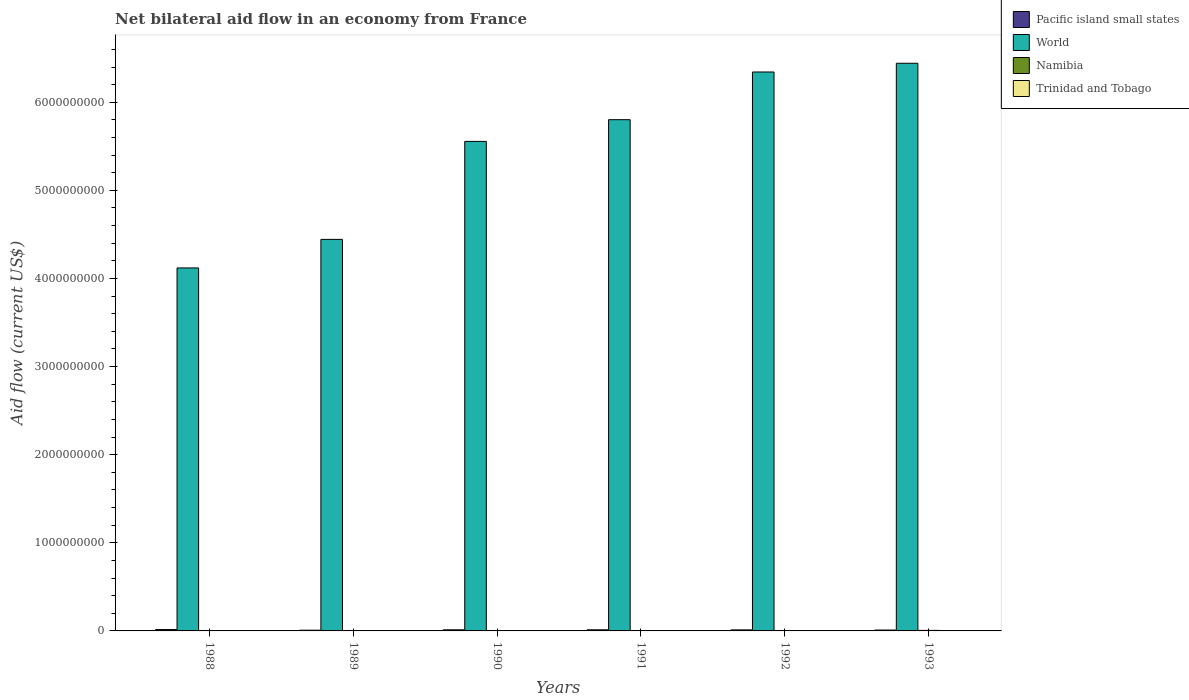How many different coloured bars are there?
Make the answer very short. 4. How many bars are there on the 1st tick from the left?
Your answer should be very brief. 4. What is the label of the 4th group of bars from the left?
Your response must be concise. 1991. What is the net bilateral aid flow in Namibia in 1989?
Your answer should be compact. 5.90e+05. Across all years, what is the maximum net bilateral aid flow in Pacific island small states?
Provide a short and direct response. 1.54e+07. Across all years, what is the minimum net bilateral aid flow in Pacific island small states?
Give a very brief answer. 8.03e+06. In which year was the net bilateral aid flow in Trinidad and Tobago minimum?
Your answer should be very brief. 1991. What is the total net bilateral aid flow in Pacific island small states in the graph?
Your answer should be compact. 7.01e+07. What is the difference between the net bilateral aid flow in Trinidad and Tobago in 1988 and that in 1992?
Ensure brevity in your answer.  -1.00e+05. What is the difference between the net bilateral aid flow in Trinidad and Tobago in 1988 and the net bilateral aid flow in Pacific island small states in 1989?
Provide a short and direct response. -7.72e+06. In the year 1992, what is the difference between the net bilateral aid flow in Namibia and net bilateral aid flow in Trinidad and Tobago?
Offer a terse response. 3.32e+06. What is the ratio of the net bilateral aid flow in Trinidad and Tobago in 1988 to that in 1989?
Provide a succinct answer. 1.03. What is the difference between the highest and the second highest net bilateral aid flow in Namibia?
Ensure brevity in your answer.  2.13e+06. What is the difference between the highest and the lowest net bilateral aid flow in Trinidad and Tobago?
Your response must be concise. 1.60e+05. Is it the case that in every year, the sum of the net bilateral aid flow in Pacific island small states and net bilateral aid flow in Namibia is greater than the sum of net bilateral aid flow in Trinidad and Tobago and net bilateral aid flow in World?
Offer a very short reply. Yes. What does the 4th bar from the left in 1989 represents?
Offer a very short reply. Trinidad and Tobago. What does the 1st bar from the right in 1991 represents?
Offer a terse response. Trinidad and Tobago. Is it the case that in every year, the sum of the net bilateral aid flow in World and net bilateral aid flow in Trinidad and Tobago is greater than the net bilateral aid flow in Pacific island small states?
Offer a terse response. Yes. How many bars are there?
Offer a very short reply. 24. Are all the bars in the graph horizontal?
Make the answer very short. No. What is the difference between two consecutive major ticks on the Y-axis?
Offer a very short reply. 1.00e+09. Where does the legend appear in the graph?
Offer a terse response. Top right. How many legend labels are there?
Your response must be concise. 4. What is the title of the graph?
Your answer should be compact. Net bilateral aid flow in an economy from France. Does "Bolivia" appear as one of the legend labels in the graph?
Your answer should be very brief. No. What is the label or title of the Y-axis?
Your answer should be very brief. Aid flow (current US$). What is the Aid flow (current US$) of Pacific island small states in 1988?
Your answer should be compact. 1.54e+07. What is the Aid flow (current US$) in World in 1988?
Offer a very short reply. 4.12e+09. What is the Aid flow (current US$) of Pacific island small states in 1989?
Your response must be concise. 8.03e+06. What is the Aid flow (current US$) in World in 1989?
Offer a terse response. 4.44e+09. What is the Aid flow (current US$) in Namibia in 1989?
Give a very brief answer. 5.90e+05. What is the Aid flow (current US$) of Trinidad and Tobago in 1989?
Your answer should be compact. 3.00e+05. What is the Aid flow (current US$) in Pacific island small states in 1990?
Offer a very short reply. 1.25e+07. What is the Aid flow (current US$) of World in 1990?
Make the answer very short. 5.56e+09. What is the Aid flow (current US$) of Namibia in 1990?
Your answer should be very brief. 1.20e+06. What is the Aid flow (current US$) of Pacific island small states in 1991?
Make the answer very short. 1.26e+07. What is the Aid flow (current US$) in World in 1991?
Make the answer very short. 5.80e+09. What is the Aid flow (current US$) in Namibia in 1991?
Your answer should be very brief. 4.02e+06. What is the Aid flow (current US$) in Pacific island small states in 1992?
Offer a very short reply. 1.16e+07. What is the Aid flow (current US$) of World in 1992?
Provide a succinct answer. 6.34e+09. What is the Aid flow (current US$) of Namibia in 1992?
Your response must be concise. 3.73e+06. What is the Aid flow (current US$) of Trinidad and Tobago in 1992?
Give a very brief answer. 4.10e+05. What is the Aid flow (current US$) in Pacific island small states in 1993?
Your answer should be compact. 9.95e+06. What is the Aid flow (current US$) of World in 1993?
Offer a very short reply. 6.44e+09. What is the Aid flow (current US$) in Namibia in 1993?
Offer a very short reply. 6.15e+06. Across all years, what is the maximum Aid flow (current US$) in Pacific island small states?
Provide a short and direct response. 1.54e+07. Across all years, what is the maximum Aid flow (current US$) of World?
Your response must be concise. 6.44e+09. Across all years, what is the maximum Aid flow (current US$) in Namibia?
Offer a terse response. 6.15e+06. Across all years, what is the maximum Aid flow (current US$) in Trinidad and Tobago?
Keep it short and to the point. 4.40e+05. Across all years, what is the minimum Aid flow (current US$) of Pacific island small states?
Provide a succinct answer. 8.03e+06. Across all years, what is the minimum Aid flow (current US$) of World?
Your answer should be very brief. 4.12e+09. Across all years, what is the minimum Aid flow (current US$) in Namibia?
Offer a terse response. 10000. What is the total Aid flow (current US$) of Pacific island small states in the graph?
Your response must be concise. 7.01e+07. What is the total Aid flow (current US$) of World in the graph?
Your answer should be compact. 3.27e+1. What is the total Aid flow (current US$) in Namibia in the graph?
Provide a short and direct response. 1.57e+07. What is the total Aid flow (current US$) of Trinidad and Tobago in the graph?
Ensure brevity in your answer.  2.04e+06. What is the difference between the Aid flow (current US$) in Pacific island small states in 1988 and that in 1989?
Keep it short and to the point. 7.34e+06. What is the difference between the Aid flow (current US$) in World in 1988 and that in 1989?
Keep it short and to the point. -3.24e+08. What is the difference between the Aid flow (current US$) in Namibia in 1988 and that in 1989?
Offer a very short reply. -5.80e+05. What is the difference between the Aid flow (current US$) of Pacific island small states in 1988 and that in 1990?
Keep it short and to the point. 2.90e+06. What is the difference between the Aid flow (current US$) in World in 1988 and that in 1990?
Keep it short and to the point. -1.44e+09. What is the difference between the Aid flow (current US$) of Namibia in 1988 and that in 1990?
Give a very brief answer. -1.19e+06. What is the difference between the Aid flow (current US$) of Trinidad and Tobago in 1988 and that in 1990?
Provide a succinct answer. -1.30e+05. What is the difference between the Aid flow (current US$) in Pacific island small states in 1988 and that in 1991?
Your response must be concise. 2.75e+06. What is the difference between the Aid flow (current US$) of World in 1988 and that in 1991?
Keep it short and to the point. -1.68e+09. What is the difference between the Aid flow (current US$) of Namibia in 1988 and that in 1991?
Keep it short and to the point. -4.01e+06. What is the difference between the Aid flow (current US$) of Trinidad and Tobago in 1988 and that in 1991?
Keep it short and to the point. 3.00e+04. What is the difference between the Aid flow (current US$) of Pacific island small states in 1988 and that in 1992?
Your response must be concise. 3.74e+06. What is the difference between the Aid flow (current US$) of World in 1988 and that in 1992?
Your response must be concise. -2.22e+09. What is the difference between the Aid flow (current US$) of Namibia in 1988 and that in 1992?
Keep it short and to the point. -3.72e+06. What is the difference between the Aid flow (current US$) of Pacific island small states in 1988 and that in 1993?
Provide a succinct answer. 5.42e+06. What is the difference between the Aid flow (current US$) of World in 1988 and that in 1993?
Your answer should be very brief. -2.32e+09. What is the difference between the Aid flow (current US$) in Namibia in 1988 and that in 1993?
Your answer should be very brief. -6.14e+06. What is the difference between the Aid flow (current US$) in Pacific island small states in 1989 and that in 1990?
Offer a very short reply. -4.44e+06. What is the difference between the Aid flow (current US$) of World in 1989 and that in 1990?
Provide a succinct answer. -1.11e+09. What is the difference between the Aid flow (current US$) of Namibia in 1989 and that in 1990?
Provide a short and direct response. -6.10e+05. What is the difference between the Aid flow (current US$) in Trinidad and Tobago in 1989 and that in 1990?
Offer a very short reply. -1.40e+05. What is the difference between the Aid flow (current US$) of Pacific island small states in 1989 and that in 1991?
Offer a very short reply. -4.59e+06. What is the difference between the Aid flow (current US$) in World in 1989 and that in 1991?
Offer a terse response. -1.36e+09. What is the difference between the Aid flow (current US$) in Namibia in 1989 and that in 1991?
Make the answer very short. -3.43e+06. What is the difference between the Aid flow (current US$) in Trinidad and Tobago in 1989 and that in 1991?
Offer a very short reply. 2.00e+04. What is the difference between the Aid flow (current US$) of Pacific island small states in 1989 and that in 1992?
Your answer should be very brief. -3.60e+06. What is the difference between the Aid flow (current US$) of World in 1989 and that in 1992?
Ensure brevity in your answer.  -1.90e+09. What is the difference between the Aid flow (current US$) in Namibia in 1989 and that in 1992?
Provide a succinct answer. -3.14e+06. What is the difference between the Aid flow (current US$) of Trinidad and Tobago in 1989 and that in 1992?
Provide a short and direct response. -1.10e+05. What is the difference between the Aid flow (current US$) in Pacific island small states in 1989 and that in 1993?
Offer a terse response. -1.92e+06. What is the difference between the Aid flow (current US$) in World in 1989 and that in 1993?
Make the answer very short. -2.00e+09. What is the difference between the Aid flow (current US$) in Namibia in 1989 and that in 1993?
Your response must be concise. -5.56e+06. What is the difference between the Aid flow (current US$) of Pacific island small states in 1990 and that in 1991?
Ensure brevity in your answer.  -1.50e+05. What is the difference between the Aid flow (current US$) in World in 1990 and that in 1991?
Your response must be concise. -2.46e+08. What is the difference between the Aid flow (current US$) in Namibia in 1990 and that in 1991?
Provide a short and direct response. -2.82e+06. What is the difference between the Aid flow (current US$) in Pacific island small states in 1990 and that in 1992?
Provide a short and direct response. 8.40e+05. What is the difference between the Aid flow (current US$) of World in 1990 and that in 1992?
Your response must be concise. -7.88e+08. What is the difference between the Aid flow (current US$) in Namibia in 1990 and that in 1992?
Provide a short and direct response. -2.53e+06. What is the difference between the Aid flow (current US$) of Trinidad and Tobago in 1990 and that in 1992?
Your answer should be very brief. 3.00e+04. What is the difference between the Aid flow (current US$) of Pacific island small states in 1990 and that in 1993?
Give a very brief answer. 2.52e+06. What is the difference between the Aid flow (current US$) in World in 1990 and that in 1993?
Offer a very short reply. -8.87e+08. What is the difference between the Aid flow (current US$) of Namibia in 1990 and that in 1993?
Provide a short and direct response. -4.95e+06. What is the difference between the Aid flow (current US$) of Pacific island small states in 1991 and that in 1992?
Make the answer very short. 9.90e+05. What is the difference between the Aid flow (current US$) of World in 1991 and that in 1992?
Offer a very short reply. -5.41e+08. What is the difference between the Aid flow (current US$) in Pacific island small states in 1991 and that in 1993?
Provide a succinct answer. 2.67e+06. What is the difference between the Aid flow (current US$) of World in 1991 and that in 1993?
Make the answer very short. -6.40e+08. What is the difference between the Aid flow (current US$) of Namibia in 1991 and that in 1993?
Offer a terse response. -2.13e+06. What is the difference between the Aid flow (current US$) in Trinidad and Tobago in 1991 and that in 1993?
Make the answer very short. -2.00e+04. What is the difference between the Aid flow (current US$) in Pacific island small states in 1992 and that in 1993?
Ensure brevity in your answer.  1.68e+06. What is the difference between the Aid flow (current US$) of World in 1992 and that in 1993?
Give a very brief answer. -9.91e+07. What is the difference between the Aid flow (current US$) of Namibia in 1992 and that in 1993?
Your response must be concise. -2.42e+06. What is the difference between the Aid flow (current US$) of Trinidad and Tobago in 1992 and that in 1993?
Give a very brief answer. 1.10e+05. What is the difference between the Aid flow (current US$) of Pacific island small states in 1988 and the Aid flow (current US$) of World in 1989?
Give a very brief answer. -4.43e+09. What is the difference between the Aid flow (current US$) of Pacific island small states in 1988 and the Aid flow (current US$) of Namibia in 1989?
Keep it short and to the point. 1.48e+07. What is the difference between the Aid flow (current US$) in Pacific island small states in 1988 and the Aid flow (current US$) in Trinidad and Tobago in 1989?
Your answer should be compact. 1.51e+07. What is the difference between the Aid flow (current US$) of World in 1988 and the Aid flow (current US$) of Namibia in 1989?
Give a very brief answer. 4.12e+09. What is the difference between the Aid flow (current US$) in World in 1988 and the Aid flow (current US$) in Trinidad and Tobago in 1989?
Provide a short and direct response. 4.12e+09. What is the difference between the Aid flow (current US$) of Pacific island small states in 1988 and the Aid flow (current US$) of World in 1990?
Ensure brevity in your answer.  -5.54e+09. What is the difference between the Aid flow (current US$) of Pacific island small states in 1988 and the Aid flow (current US$) of Namibia in 1990?
Ensure brevity in your answer.  1.42e+07. What is the difference between the Aid flow (current US$) in Pacific island small states in 1988 and the Aid flow (current US$) in Trinidad and Tobago in 1990?
Ensure brevity in your answer.  1.49e+07. What is the difference between the Aid flow (current US$) of World in 1988 and the Aid flow (current US$) of Namibia in 1990?
Provide a succinct answer. 4.12e+09. What is the difference between the Aid flow (current US$) of World in 1988 and the Aid flow (current US$) of Trinidad and Tobago in 1990?
Make the answer very short. 4.12e+09. What is the difference between the Aid flow (current US$) in Namibia in 1988 and the Aid flow (current US$) in Trinidad and Tobago in 1990?
Give a very brief answer. -4.30e+05. What is the difference between the Aid flow (current US$) of Pacific island small states in 1988 and the Aid flow (current US$) of World in 1991?
Ensure brevity in your answer.  -5.79e+09. What is the difference between the Aid flow (current US$) in Pacific island small states in 1988 and the Aid flow (current US$) in Namibia in 1991?
Your response must be concise. 1.14e+07. What is the difference between the Aid flow (current US$) of Pacific island small states in 1988 and the Aid flow (current US$) of Trinidad and Tobago in 1991?
Offer a terse response. 1.51e+07. What is the difference between the Aid flow (current US$) in World in 1988 and the Aid flow (current US$) in Namibia in 1991?
Your answer should be very brief. 4.12e+09. What is the difference between the Aid flow (current US$) of World in 1988 and the Aid flow (current US$) of Trinidad and Tobago in 1991?
Make the answer very short. 4.12e+09. What is the difference between the Aid flow (current US$) in Namibia in 1988 and the Aid flow (current US$) in Trinidad and Tobago in 1991?
Your answer should be compact. -2.70e+05. What is the difference between the Aid flow (current US$) of Pacific island small states in 1988 and the Aid flow (current US$) of World in 1992?
Ensure brevity in your answer.  -6.33e+09. What is the difference between the Aid flow (current US$) of Pacific island small states in 1988 and the Aid flow (current US$) of Namibia in 1992?
Your response must be concise. 1.16e+07. What is the difference between the Aid flow (current US$) of Pacific island small states in 1988 and the Aid flow (current US$) of Trinidad and Tobago in 1992?
Provide a succinct answer. 1.50e+07. What is the difference between the Aid flow (current US$) in World in 1988 and the Aid flow (current US$) in Namibia in 1992?
Give a very brief answer. 4.12e+09. What is the difference between the Aid flow (current US$) of World in 1988 and the Aid flow (current US$) of Trinidad and Tobago in 1992?
Make the answer very short. 4.12e+09. What is the difference between the Aid flow (current US$) in Namibia in 1988 and the Aid flow (current US$) in Trinidad and Tobago in 1992?
Your answer should be compact. -4.00e+05. What is the difference between the Aid flow (current US$) of Pacific island small states in 1988 and the Aid flow (current US$) of World in 1993?
Provide a short and direct response. -6.43e+09. What is the difference between the Aid flow (current US$) of Pacific island small states in 1988 and the Aid flow (current US$) of Namibia in 1993?
Keep it short and to the point. 9.22e+06. What is the difference between the Aid flow (current US$) in Pacific island small states in 1988 and the Aid flow (current US$) in Trinidad and Tobago in 1993?
Provide a succinct answer. 1.51e+07. What is the difference between the Aid flow (current US$) of World in 1988 and the Aid flow (current US$) of Namibia in 1993?
Your answer should be very brief. 4.11e+09. What is the difference between the Aid flow (current US$) in World in 1988 and the Aid flow (current US$) in Trinidad and Tobago in 1993?
Provide a short and direct response. 4.12e+09. What is the difference between the Aid flow (current US$) in Namibia in 1988 and the Aid flow (current US$) in Trinidad and Tobago in 1993?
Give a very brief answer. -2.90e+05. What is the difference between the Aid flow (current US$) in Pacific island small states in 1989 and the Aid flow (current US$) in World in 1990?
Make the answer very short. -5.55e+09. What is the difference between the Aid flow (current US$) in Pacific island small states in 1989 and the Aid flow (current US$) in Namibia in 1990?
Your answer should be very brief. 6.83e+06. What is the difference between the Aid flow (current US$) in Pacific island small states in 1989 and the Aid flow (current US$) in Trinidad and Tobago in 1990?
Provide a succinct answer. 7.59e+06. What is the difference between the Aid flow (current US$) of World in 1989 and the Aid flow (current US$) of Namibia in 1990?
Your response must be concise. 4.44e+09. What is the difference between the Aid flow (current US$) in World in 1989 and the Aid flow (current US$) in Trinidad and Tobago in 1990?
Ensure brevity in your answer.  4.44e+09. What is the difference between the Aid flow (current US$) of Namibia in 1989 and the Aid flow (current US$) of Trinidad and Tobago in 1990?
Your response must be concise. 1.50e+05. What is the difference between the Aid flow (current US$) of Pacific island small states in 1989 and the Aid flow (current US$) of World in 1991?
Provide a short and direct response. -5.79e+09. What is the difference between the Aid flow (current US$) of Pacific island small states in 1989 and the Aid flow (current US$) of Namibia in 1991?
Give a very brief answer. 4.01e+06. What is the difference between the Aid flow (current US$) of Pacific island small states in 1989 and the Aid flow (current US$) of Trinidad and Tobago in 1991?
Offer a terse response. 7.75e+06. What is the difference between the Aid flow (current US$) of World in 1989 and the Aid flow (current US$) of Namibia in 1991?
Make the answer very short. 4.44e+09. What is the difference between the Aid flow (current US$) in World in 1989 and the Aid flow (current US$) in Trinidad and Tobago in 1991?
Offer a terse response. 4.44e+09. What is the difference between the Aid flow (current US$) in Namibia in 1989 and the Aid flow (current US$) in Trinidad and Tobago in 1991?
Give a very brief answer. 3.10e+05. What is the difference between the Aid flow (current US$) of Pacific island small states in 1989 and the Aid flow (current US$) of World in 1992?
Make the answer very short. -6.34e+09. What is the difference between the Aid flow (current US$) of Pacific island small states in 1989 and the Aid flow (current US$) of Namibia in 1992?
Your answer should be compact. 4.30e+06. What is the difference between the Aid flow (current US$) of Pacific island small states in 1989 and the Aid flow (current US$) of Trinidad and Tobago in 1992?
Your answer should be compact. 7.62e+06. What is the difference between the Aid flow (current US$) of World in 1989 and the Aid flow (current US$) of Namibia in 1992?
Your answer should be very brief. 4.44e+09. What is the difference between the Aid flow (current US$) of World in 1989 and the Aid flow (current US$) of Trinidad and Tobago in 1992?
Ensure brevity in your answer.  4.44e+09. What is the difference between the Aid flow (current US$) in Pacific island small states in 1989 and the Aid flow (current US$) in World in 1993?
Your response must be concise. -6.43e+09. What is the difference between the Aid flow (current US$) in Pacific island small states in 1989 and the Aid flow (current US$) in Namibia in 1993?
Make the answer very short. 1.88e+06. What is the difference between the Aid flow (current US$) in Pacific island small states in 1989 and the Aid flow (current US$) in Trinidad and Tobago in 1993?
Provide a short and direct response. 7.73e+06. What is the difference between the Aid flow (current US$) of World in 1989 and the Aid flow (current US$) of Namibia in 1993?
Make the answer very short. 4.44e+09. What is the difference between the Aid flow (current US$) in World in 1989 and the Aid flow (current US$) in Trinidad and Tobago in 1993?
Offer a very short reply. 4.44e+09. What is the difference between the Aid flow (current US$) of Pacific island small states in 1990 and the Aid flow (current US$) of World in 1991?
Ensure brevity in your answer.  -5.79e+09. What is the difference between the Aid flow (current US$) of Pacific island small states in 1990 and the Aid flow (current US$) of Namibia in 1991?
Your answer should be compact. 8.45e+06. What is the difference between the Aid flow (current US$) in Pacific island small states in 1990 and the Aid flow (current US$) in Trinidad and Tobago in 1991?
Give a very brief answer. 1.22e+07. What is the difference between the Aid flow (current US$) of World in 1990 and the Aid flow (current US$) of Namibia in 1991?
Give a very brief answer. 5.55e+09. What is the difference between the Aid flow (current US$) in World in 1990 and the Aid flow (current US$) in Trinidad and Tobago in 1991?
Your response must be concise. 5.56e+09. What is the difference between the Aid flow (current US$) in Namibia in 1990 and the Aid flow (current US$) in Trinidad and Tobago in 1991?
Make the answer very short. 9.20e+05. What is the difference between the Aid flow (current US$) in Pacific island small states in 1990 and the Aid flow (current US$) in World in 1992?
Your answer should be very brief. -6.33e+09. What is the difference between the Aid flow (current US$) in Pacific island small states in 1990 and the Aid flow (current US$) in Namibia in 1992?
Make the answer very short. 8.74e+06. What is the difference between the Aid flow (current US$) in Pacific island small states in 1990 and the Aid flow (current US$) in Trinidad and Tobago in 1992?
Provide a succinct answer. 1.21e+07. What is the difference between the Aid flow (current US$) of World in 1990 and the Aid flow (current US$) of Namibia in 1992?
Make the answer very short. 5.55e+09. What is the difference between the Aid flow (current US$) in World in 1990 and the Aid flow (current US$) in Trinidad and Tobago in 1992?
Provide a short and direct response. 5.56e+09. What is the difference between the Aid flow (current US$) of Namibia in 1990 and the Aid flow (current US$) of Trinidad and Tobago in 1992?
Give a very brief answer. 7.90e+05. What is the difference between the Aid flow (current US$) in Pacific island small states in 1990 and the Aid flow (current US$) in World in 1993?
Give a very brief answer. -6.43e+09. What is the difference between the Aid flow (current US$) in Pacific island small states in 1990 and the Aid flow (current US$) in Namibia in 1993?
Make the answer very short. 6.32e+06. What is the difference between the Aid flow (current US$) in Pacific island small states in 1990 and the Aid flow (current US$) in Trinidad and Tobago in 1993?
Offer a terse response. 1.22e+07. What is the difference between the Aid flow (current US$) of World in 1990 and the Aid flow (current US$) of Namibia in 1993?
Your answer should be compact. 5.55e+09. What is the difference between the Aid flow (current US$) of World in 1990 and the Aid flow (current US$) of Trinidad and Tobago in 1993?
Your answer should be compact. 5.56e+09. What is the difference between the Aid flow (current US$) of Namibia in 1990 and the Aid flow (current US$) of Trinidad and Tobago in 1993?
Ensure brevity in your answer.  9.00e+05. What is the difference between the Aid flow (current US$) of Pacific island small states in 1991 and the Aid flow (current US$) of World in 1992?
Provide a short and direct response. -6.33e+09. What is the difference between the Aid flow (current US$) of Pacific island small states in 1991 and the Aid flow (current US$) of Namibia in 1992?
Keep it short and to the point. 8.89e+06. What is the difference between the Aid flow (current US$) in Pacific island small states in 1991 and the Aid flow (current US$) in Trinidad and Tobago in 1992?
Provide a succinct answer. 1.22e+07. What is the difference between the Aid flow (current US$) in World in 1991 and the Aid flow (current US$) in Namibia in 1992?
Provide a short and direct response. 5.80e+09. What is the difference between the Aid flow (current US$) in World in 1991 and the Aid flow (current US$) in Trinidad and Tobago in 1992?
Provide a short and direct response. 5.80e+09. What is the difference between the Aid flow (current US$) of Namibia in 1991 and the Aid flow (current US$) of Trinidad and Tobago in 1992?
Your answer should be compact. 3.61e+06. What is the difference between the Aid flow (current US$) in Pacific island small states in 1991 and the Aid flow (current US$) in World in 1993?
Your response must be concise. -6.43e+09. What is the difference between the Aid flow (current US$) of Pacific island small states in 1991 and the Aid flow (current US$) of Namibia in 1993?
Provide a short and direct response. 6.47e+06. What is the difference between the Aid flow (current US$) in Pacific island small states in 1991 and the Aid flow (current US$) in Trinidad and Tobago in 1993?
Keep it short and to the point. 1.23e+07. What is the difference between the Aid flow (current US$) in World in 1991 and the Aid flow (current US$) in Namibia in 1993?
Make the answer very short. 5.80e+09. What is the difference between the Aid flow (current US$) in World in 1991 and the Aid flow (current US$) in Trinidad and Tobago in 1993?
Provide a succinct answer. 5.80e+09. What is the difference between the Aid flow (current US$) of Namibia in 1991 and the Aid flow (current US$) of Trinidad and Tobago in 1993?
Keep it short and to the point. 3.72e+06. What is the difference between the Aid flow (current US$) of Pacific island small states in 1992 and the Aid flow (current US$) of World in 1993?
Make the answer very short. -6.43e+09. What is the difference between the Aid flow (current US$) in Pacific island small states in 1992 and the Aid flow (current US$) in Namibia in 1993?
Make the answer very short. 5.48e+06. What is the difference between the Aid flow (current US$) in Pacific island small states in 1992 and the Aid flow (current US$) in Trinidad and Tobago in 1993?
Your answer should be compact. 1.13e+07. What is the difference between the Aid flow (current US$) of World in 1992 and the Aid flow (current US$) of Namibia in 1993?
Ensure brevity in your answer.  6.34e+09. What is the difference between the Aid flow (current US$) in World in 1992 and the Aid flow (current US$) in Trinidad and Tobago in 1993?
Your response must be concise. 6.34e+09. What is the difference between the Aid flow (current US$) of Namibia in 1992 and the Aid flow (current US$) of Trinidad and Tobago in 1993?
Make the answer very short. 3.43e+06. What is the average Aid flow (current US$) of Pacific island small states per year?
Offer a terse response. 1.17e+07. What is the average Aid flow (current US$) of World per year?
Offer a terse response. 5.45e+09. What is the average Aid flow (current US$) of Namibia per year?
Provide a succinct answer. 2.62e+06. In the year 1988, what is the difference between the Aid flow (current US$) in Pacific island small states and Aid flow (current US$) in World?
Make the answer very short. -4.10e+09. In the year 1988, what is the difference between the Aid flow (current US$) of Pacific island small states and Aid flow (current US$) of Namibia?
Give a very brief answer. 1.54e+07. In the year 1988, what is the difference between the Aid flow (current US$) in Pacific island small states and Aid flow (current US$) in Trinidad and Tobago?
Make the answer very short. 1.51e+07. In the year 1988, what is the difference between the Aid flow (current US$) in World and Aid flow (current US$) in Namibia?
Offer a terse response. 4.12e+09. In the year 1988, what is the difference between the Aid flow (current US$) in World and Aid flow (current US$) in Trinidad and Tobago?
Give a very brief answer. 4.12e+09. In the year 1989, what is the difference between the Aid flow (current US$) of Pacific island small states and Aid flow (current US$) of World?
Ensure brevity in your answer.  -4.44e+09. In the year 1989, what is the difference between the Aid flow (current US$) of Pacific island small states and Aid flow (current US$) of Namibia?
Give a very brief answer. 7.44e+06. In the year 1989, what is the difference between the Aid flow (current US$) in Pacific island small states and Aid flow (current US$) in Trinidad and Tobago?
Make the answer very short. 7.73e+06. In the year 1989, what is the difference between the Aid flow (current US$) in World and Aid flow (current US$) in Namibia?
Your answer should be compact. 4.44e+09. In the year 1989, what is the difference between the Aid flow (current US$) in World and Aid flow (current US$) in Trinidad and Tobago?
Make the answer very short. 4.44e+09. In the year 1990, what is the difference between the Aid flow (current US$) of Pacific island small states and Aid flow (current US$) of World?
Give a very brief answer. -5.54e+09. In the year 1990, what is the difference between the Aid flow (current US$) of Pacific island small states and Aid flow (current US$) of Namibia?
Your answer should be very brief. 1.13e+07. In the year 1990, what is the difference between the Aid flow (current US$) in Pacific island small states and Aid flow (current US$) in Trinidad and Tobago?
Provide a succinct answer. 1.20e+07. In the year 1990, what is the difference between the Aid flow (current US$) in World and Aid flow (current US$) in Namibia?
Ensure brevity in your answer.  5.55e+09. In the year 1990, what is the difference between the Aid flow (current US$) in World and Aid flow (current US$) in Trinidad and Tobago?
Provide a succinct answer. 5.56e+09. In the year 1990, what is the difference between the Aid flow (current US$) of Namibia and Aid flow (current US$) of Trinidad and Tobago?
Give a very brief answer. 7.60e+05. In the year 1991, what is the difference between the Aid flow (current US$) of Pacific island small states and Aid flow (current US$) of World?
Keep it short and to the point. -5.79e+09. In the year 1991, what is the difference between the Aid flow (current US$) in Pacific island small states and Aid flow (current US$) in Namibia?
Your response must be concise. 8.60e+06. In the year 1991, what is the difference between the Aid flow (current US$) of Pacific island small states and Aid flow (current US$) of Trinidad and Tobago?
Your answer should be very brief. 1.23e+07. In the year 1991, what is the difference between the Aid flow (current US$) in World and Aid flow (current US$) in Namibia?
Your answer should be compact. 5.80e+09. In the year 1991, what is the difference between the Aid flow (current US$) in World and Aid flow (current US$) in Trinidad and Tobago?
Offer a very short reply. 5.80e+09. In the year 1991, what is the difference between the Aid flow (current US$) of Namibia and Aid flow (current US$) of Trinidad and Tobago?
Your answer should be very brief. 3.74e+06. In the year 1992, what is the difference between the Aid flow (current US$) in Pacific island small states and Aid flow (current US$) in World?
Give a very brief answer. -6.33e+09. In the year 1992, what is the difference between the Aid flow (current US$) of Pacific island small states and Aid flow (current US$) of Namibia?
Give a very brief answer. 7.90e+06. In the year 1992, what is the difference between the Aid flow (current US$) of Pacific island small states and Aid flow (current US$) of Trinidad and Tobago?
Your answer should be very brief. 1.12e+07. In the year 1992, what is the difference between the Aid flow (current US$) in World and Aid flow (current US$) in Namibia?
Offer a very short reply. 6.34e+09. In the year 1992, what is the difference between the Aid flow (current US$) of World and Aid flow (current US$) of Trinidad and Tobago?
Offer a very short reply. 6.34e+09. In the year 1992, what is the difference between the Aid flow (current US$) in Namibia and Aid flow (current US$) in Trinidad and Tobago?
Give a very brief answer. 3.32e+06. In the year 1993, what is the difference between the Aid flow (current US$) in Pacific island small states and Aid flow (current US$) in World?
Offer a terse response. -6.43e+09. In the year 1993, what is the difference between the Aid flow (current US$) in Pacific island small states and Aid flow (current US$) in Namibia?
Your response must be concise. 3.80e+06. In the year 1993, what is the difference between the Aid flow (current US$) in Pacific island small states and Aid flow (current US$) in Trinidad and Tobago?
Keep it short and to the point. 9.65e+06. In the year 1993, what is the difference between the Aid flow (current US$) in World and Aid flow (current US$) in Namibia?
Offer a very short reply. 6.44e+09. In the year 1993, what is the difference between the Aid flow (current US$) of World and Aid flow (current US$) of Trinidad and Tobago?
Your answer should be very brief. 6.44e+09. In the year 1993, what is the difference between the Aid flow (current US$) of Namibia and Aid flow (current US$) of Trinidad and Tobago?
Ensure brevity in your answer.  5.85e+06. What is the ratio of the Aid flow (current US$) of Pacific island small states in 1988 to that in 1989?
Offer a very short reply. 1.91. What is the ratio of the Aid flow (current US$) of World in 1988 to that in 1989?
Your answer should be compact. 0.93. What is the ratio of the Aid flow (current US$) of Namibia in 1988 to that in 1989?
Your answer should be compact. 0.02. What is the ratio of the Aid flow (current US$) of Trinidad and Tobago in 1988 to that in 1989?
Ensure brevity in your answer.  1.03. What is the ratio of the Aid flow (current US$) in Pacific island small states in 1988 to that in 1990?
Ensure brevity in your answer.  1.23. What is the ratio of the Aid flow (current US$) of World in 1988 to that in 1990?
Your answer should be compact. 0.74. What is the ratio of the Aid flow (current US$) in Namibia in 1988 to that in 1990?
Make the answer very short. 0.01. What is the ratio of the Aid flow (current US$) of Trinidad and Tobago in 1988 to that in 1990?
Ensure brevity in your answer.  0.7. What is the ratio of the Aid flow (current US$) of Pacific island small states in 1988 to that in 1991?
Provide a succinct answer. 1.22. What is the ratio of the Aid flow (current US$) in World in 1988 to that in 1991?
Provide a short and direct response. 0.71. What is the ratio of the Aid flow (current US$) of Namibia in 1988 to that in 1991?
Offer a very short reply. 0. What is the ratio of the Aid flow (current US$) in Trinidad and Tobago in 1988 to that in 1991?
Ensure brevity in your answer.  1.11. What is the ratio of the Aid flow (current US$) of Pacific island small states in 1988 to that in 1992?
Offer a terse response. 1.32. What is the ratio of the Aid flow (current US$) of World in 1988 to that in 1992?
Ensure brevity in your answer.  0.65. What is the ratio of the Aid flow (current US$) in Namibia in 1988 to that in 1992?
Keep it short and to the point. 0. What is the ratio of the Aid flow (current US$) in Trinidad and Tobago in 1988 to that in 1992?
Give a very brief answer. 0.76. What is the ratio of the Aid flow (current US$) in Pacific island small states in 1988 to that in 1993?
Your answer should be very brief. 1.54. What is the ratio of the Aid flow (current US$) of World in 1988 to that in 1993?
Provide a succinct answer. 0.64. What is the ratio of the Aid flow (current US$) in Namibia in 1988 to that in 1993?
Your answer should be compact. 0. What is the ratio of the Aid flow (current US$) of Pacific island small states in 1989 to that in 1990?
Give a very brief answer. 0.64. What is the ratio of the Aid flow (current US$) in World in 1989 to that in 1990?
Provide a succinct answer. 0.8. What is the ratio of the Aid flow (current US$) in Namibia in 1989 to that in 1990?
Provide a short and direct response. 0.49. What is the ratio of the Aid flow (current US$) of Trinidad and Tobago in 1989 to that in 1990?
Your answer should be very brief. 0.68. What is the ratio of the Aid flow (current US$) in Pacific island small states in 1989 to that in 1991?
Ensure brevity in your answer.  0.64. What is the ratio of the Aid flow (current US$) of World in 1989 to that in 1991?
Keep it short and to the point. 0.77. What is the ratio of the Aid flow (current US$) of Namibia in 1989 to that in 1991?
Give a very brief answer. 0.15. What is the ratio of the Aid flow (current US$) in Trinidad and Tobago in 1989 to that in 1991?
Your response must be concise. 1.07. What is the ratio of the Aid flow (current US$) of Pacific island small states in 1989 to that in 1992?
Your response must be concise. 0.69. What is the ratio of the Aid flow (current US$) of World in 1989 to that in 1992?
Your answer should be very brief. 0.7. What is the ratio of the Aid flow (current US$) in Namibia in 1989 to that in 1992?
Your answer should be compact. 0.16. What is the ratio of the Aid flow (current US$) of Trinidad and Tobago in 1989 to that in 1992?
Provide a succinct answer. 0.73. What is the ratio of the Aid flow (current US$) in Pacific island small states in 1989 to that in 1993?
Ensure brevity in your answer.  0.81. What is the ratio of the Aid flow (current US$) in World in 1989 to that in 1993?
Make the answer very short. 0.69. What is the ratio of the Aid flow (current US$) in Namibia in 1989 to that in 1993?
Keep it short and to the point. 0.1. What is the ratio of the Aid flow (current US$) in Pacific island small states in 1990 to that in 1991?
Your response must be concise. 0.99. What is the ratio of the Aid flow (current US$) of World in 1990 to that in 1991?
Keep it short and to the point. 0.96. What is the ratio of the Aid flow (current US$) in Namibia in 1990 to that in 1991?
Ensure brevity in your answer.  0.3. What is the ratio of the Aid flow (current US$) in Trinidad and Tobago in 1990 to that in 1991?
Keep it short and to the point. 1.57. What is the ratio of the Aid flow (current US$) of Pacific island small states in 1990 to that in 1992?
Your answer should be compact. 1.07. What is the ratio of the Aid flow (current US$) of World in 1990 to that in 1992?
Ensure brevity in your answer.  0.88. What is the ratio of the Aid flow (current US$) in Namibia in 1990 to that in 1992?
Your response must be concise. 0.32. What is the ratio of the Aid flow (current US$) of Trinidad and Tobago in 1990 to that in 1992?
Offer a very short reply. 1.07. What is the ratio of the Aid flow (current US$) in Pacific island small states in 1990 to that in 1993?
Make the answer very short. 1.25. What is the ratio of the Aid flow (current US$) of World in 1990 to that in 1993?
Your answer should be very brief. 0.86. What is the ratio of the Aid flow (current US$) in Namibia in 1990 to that in 1993?
Offer a terse response. 0.2. What is the ratio of the Aid flow (current US$) of Trinidad and Tobago in 1990 to that in 1993?
Keep it short and to the point. 1.47. What is the ratio of the Aid flow (current US$) in Pacific island small states in 1991 to that in 1992?
Provide a short and direct response. 1.09. What is the ratio of the Aid flow (current US$) in World in 1991 to that in 1992?
Provide a succinct answer. 0.91. What is the ratio of the Aid flow (current US$) of Namibia in 1991 to that in 1992?
Your response must be concise. 1.08. What is the ratio of the Aid flow (current US$) of Trinidad and Tobago in 1991 to that in 1992?
Your answer should be compact. 0.68. What is the ratio of the Aid flow (current US$) in Pacific island small states in 1991 to that in 1993?
Keep it short and to the point. 1.27. What is the ratio of the Aid flow (current US$) of World in 1991 to that in 1993?
Offer a very short reply. 0.9. What is the ratio of the Aid flow (current US$) in Namibia in 1991 to that in 1993?
Offer a very short reply. 0.65. What is the ratio of the Aid flow (current US$) in Trinidad and Tobago in 1991 to that in 1993?
Offer a terse response. 0.93. What is the ratio of the Aid flow (current US$) in Pacific island small states in 1992 to that in 1993?
Ensure brevity in your answer.  1.17. What is the ratio of the Aid flow (current US$) in World in 1992 to that in 1993?
Make the answer very short. 0.98. What is the ratio of the Aid flow (current US$) of Namibia in 1992 to that in 1993?
Your response must be concise. 0.61. What is the ratio of the Aid flow (current US$) of Trinidad and Tobago in 1992 to that in 1993?
Your answer should be compact. 1.37. What is the difference between the highest and the second highest Aid flow (current US$) in Pacific island small states?
Give a very brief answer. 2.75e+06. What is the difference between the highest and the second highest Aid flow (current US$) in World?
Provide a short and direct response. 9.91e+07. What is the difference between the highest and the second highest Aid flow (current US$) of Namibia?
Your response must be concise. 2.13e+06. What is the difference between the highest and the second highest Aid flow (current US$) in Trinidad and Tobago?
Offer a very short reply. 3.00e+04. What is the difference between the highest and the lowest Aid flow (current US$) of Pacific island small states?
Offer a terse response. 7.34e+06. What is the difference between the highest and the lowest Aid flow (current US$) of World?
Give a very brief answer. 2.32e+09. What is the difference between the highest and the lowest Aid flow (current US$) of Namibia?
Give a very brief answer. 6.14e+06. What is the difference between the highest and the lowest Aid flow (current US$) of Trinidad and Tobago?
Keep it short and to the point. 1.60e+05. 